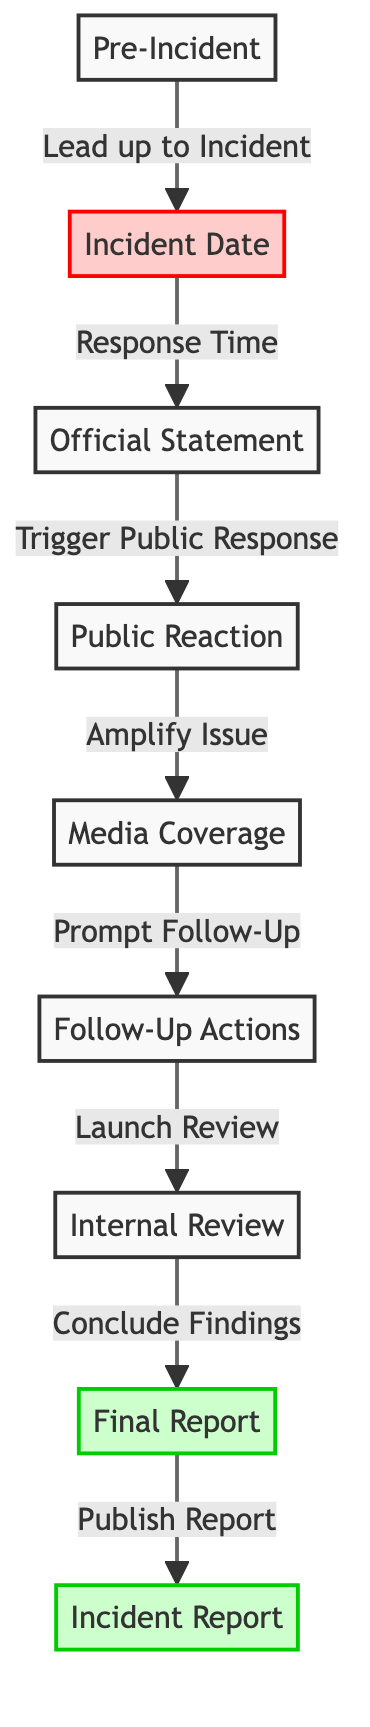What is the first node in the diagram? The first node is labeled "Pre-Incident". It is positioned at the top of the flowchart, before any arrows lead to other events.
Answer: Pre-Incident How many nodes are in the diagram? The diagram contains a total of eight nodes, which includes all events and reports listed in the flowchart.
Answer: Eight What does the official statement trigger? The official statement triggers a public response, as indicated by the directed arrow leading from "Official Statement" to "Public Reaction".
Answer: Public Reaction Which node follows the media coverage? The node that follows media coverage is "Follow-Up Actions". This can be seen in the flow from "Media Coverage" leading downward to the next event.
Answer: Follow-Up Actions What type of document is published after the final report? The document published after the final report is the "Incident Report", as shown by the arrow flowing from "Final Report" to "Incident Report".
Answer: Incident Report How does the public reaction impact the subsequent elements in the diagram? The public reaction amplifies the issue, which connects it directly to the media coverage, showing the influence of public sentiment on media engagement.
Answer: Amplify Issue What action is taken immediately after the follow-up actions? The action taken immediately after the follow-up actions is the launch of an internal review, following the directed flow in the diagram.
Answer: Launch Review What is the significance of the final report node in terms of the overall structure? The final report serves as a pivotal point in the diagram, as it leads directly to the publication of the incident report, indicating the completion of the review process.
Answer: Publication of Incident Report 